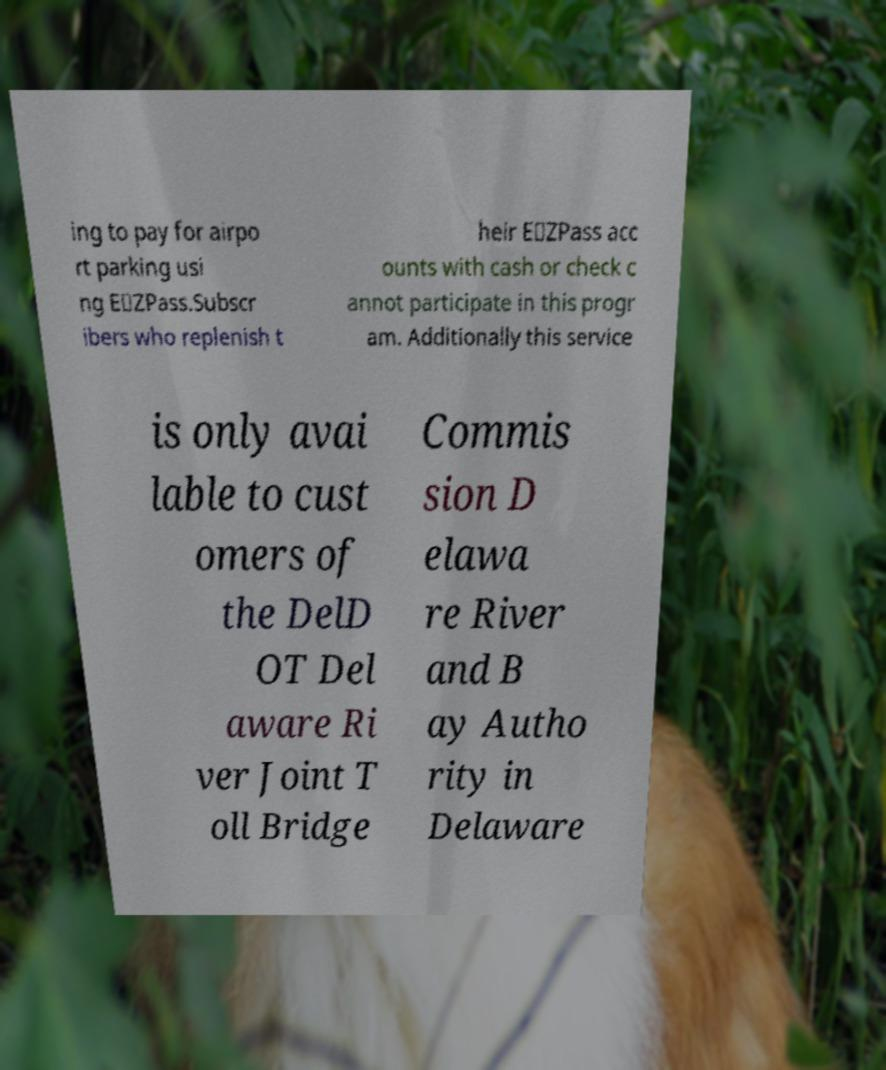I need the written content from this picture converted into text. Can you do that? ing to pay for airpo rt parking usi ng E‑ZPass.Subscr ibers who replenish t heir E‑ZPass acc ounts with cash or check c annot participate in this progr am. Additionally this service is only avai lable to cust omers of the DelD OT Del aware Ri ver Joint T oll Bridge Commis sion D elawa re River and B ay Autho rity in Delaware 